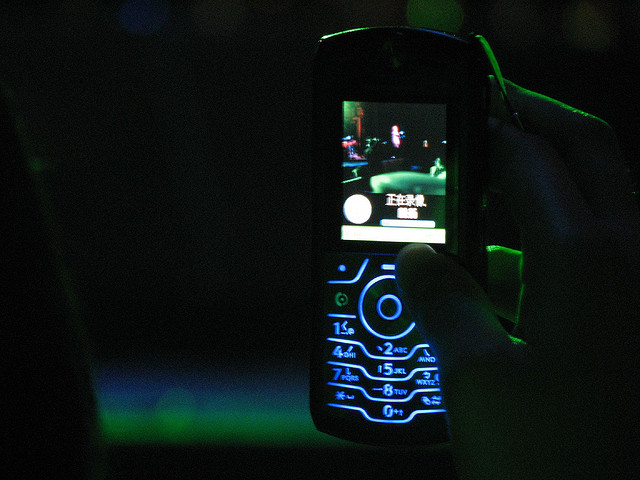Read and extract the text from this image. 1 4 2 7 8 5 